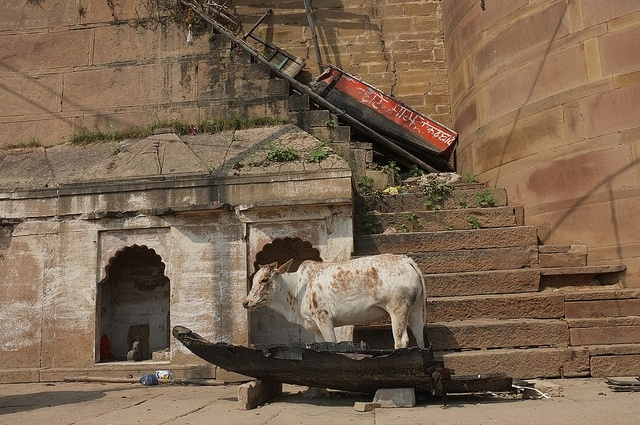Describe the objects in this image and their specific colors. I can see a cow in gray and tan tones in this image. 